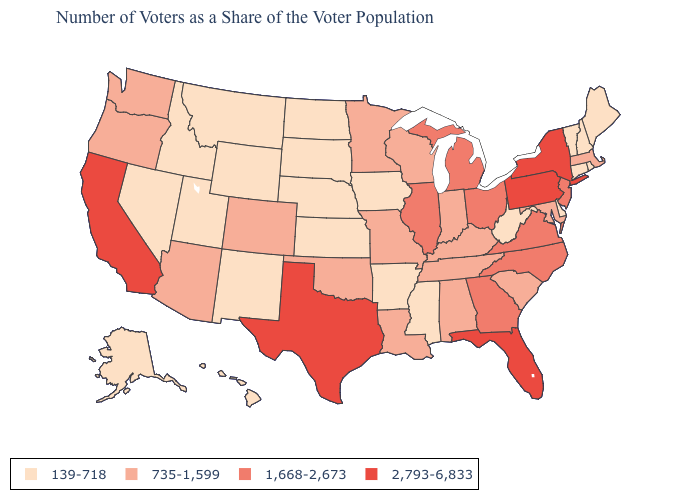Does Iowa have a lower value than Washington?
Give a very brief answer. Yes. What is the value of Arizona?
Be succinct. 735-1,599. Among the states that border Oklahoma , which have the highest value?
Write a very short answer. Texas. How many symbols are there in the legend?
Quick response, please. 4. Does Nebraska have the highest value in the MidWest?
Quick response, please. No. What is the lowest value in states that border Delaware?
Short answer required. 735-1,599. Does New York have a higher value than New Hampshire?
Be succinct. Yes. Among the states that border Indiana , does Michigan have the highest value?
Give a very brief answer. Yes. What is the lowest value in the South?
Keep it brief. 139-718. Name the states that have a value in the range 139-718?
Write a very short answer. Alaska, Arkansas, Connecticut, Delaware, Hawaii, Idaho, Iowa, Kansas, Maine, Mississippi, Montana, Nebraska, Nevada, New Hampshire, New Mexico, North Dakota, Rhode Island, South Dakota, Utah, Vermont, West Virginia, Wyoming. Name the states that have a value in the range 139-718?
Keep it brief. Alaska, Arkansas, Connecticut, Delaware, Hawaii, Idaho, Iowa, Kansas, Maine, Mississippi, Montana, Nebraska, Nevada, New Hampshire, New Mexico, North Dakota, Rhode Island, South Dakota, Utah, Vermont, West Virginia, Wyoming. What is the lowest value in states that border California?
Write a very short answer. 139-718. Name the states that have a value in the range 2,793-6,833?
Concise answer only. California, Florida, New York, Pennsylvania, Texas. Name the states that have a value in the range 735-1,599?
Answer briefly. Alabama, Arizona, Colorado, Indiana, Kentucky, Louisiana, Maryland, Massachusetts, Minnesota, Missouri, Oklahoma, Oregon, South Carolina, Tennessee, Washington, Wisconsin. What is the lowest value in the Northeast?
Answer briefly. 139-718. 